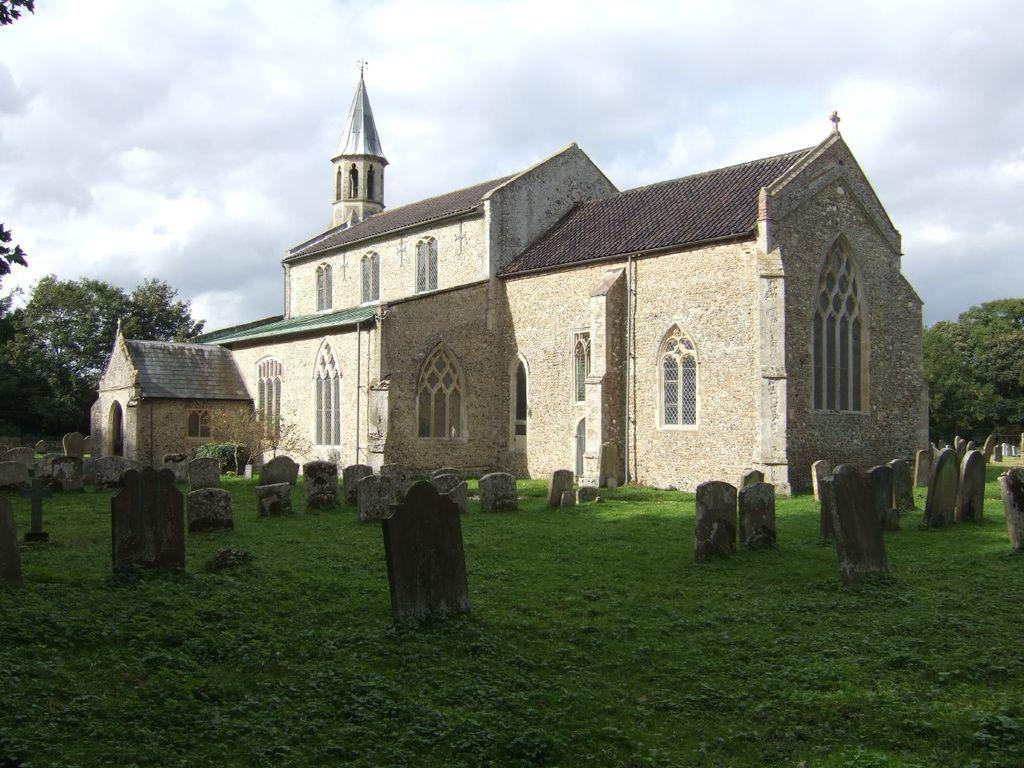What type of location is depicted in the image? There are gravesites in the image, which suggests it is a cemetery or a similar location. What structure can be seen in the image? There is a building in the image. What can be seen in the sky in the image? The sky is visible in the image. What type of vegetation is visible in the background of the image? There are trees in the background of the image. Can you see a flock of birds sitting on the throne in the image? There is no throne present in the image. 